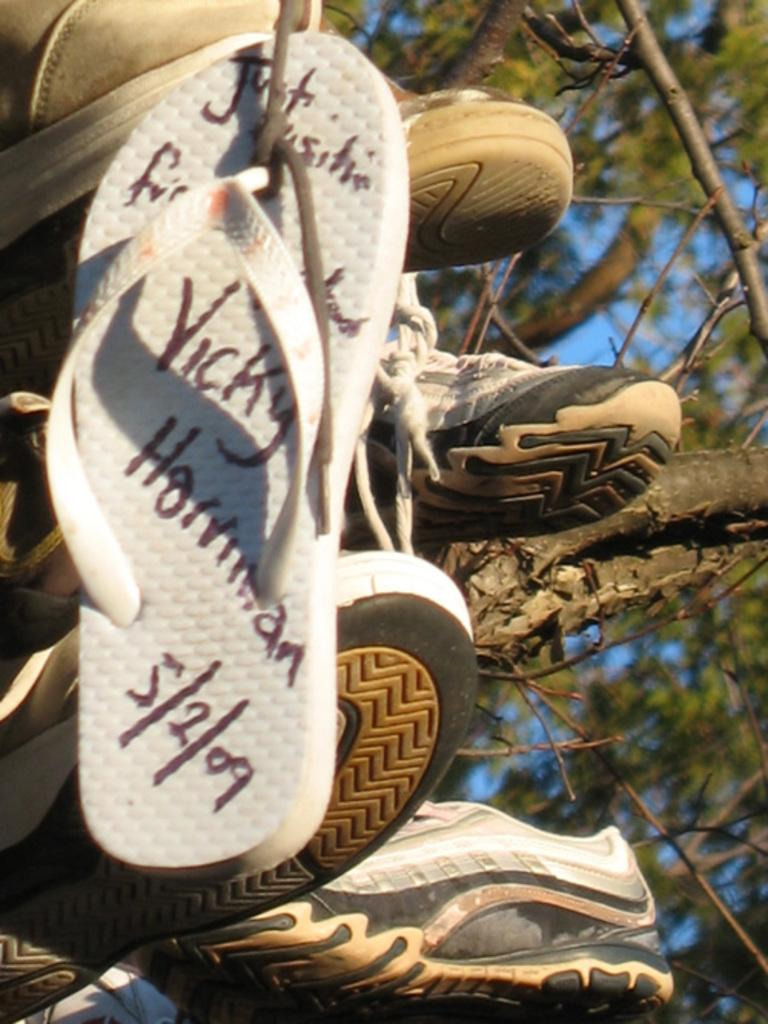What type of objects can be seen in the image? There are shoes in the image. What else is present in the image besides shoes? There are trees in the image. Can you see a picture of a robin on one of the shoes in the image? There is no picture of a robin on any of the shoes in the image. Is there a trail visible in the image? There is no trail visible in the image; it only features shoes and trees. 